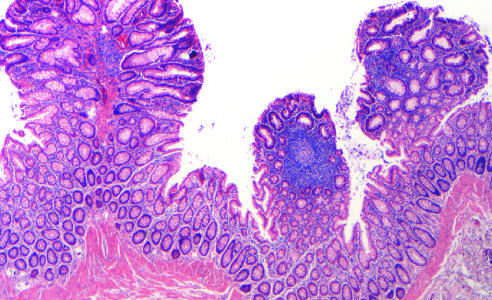re loosely formed interstitial granulomas and chronic inflammation present in this single microscopic field?
Answer the question using a single word or phrase. No 